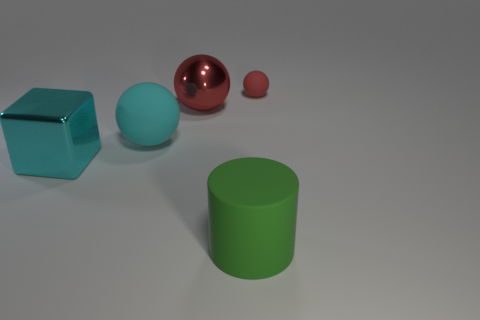Subtract all small rubber spheres. How many spheres are left? 2 Add 5 red rubber spheres. How many objects exist? 10 Subtract all cyan cylinders. How many red balls are left? 2 Subtract 1 cylinders. How many cylinders are left? 0 Subtract all blocks. How many objects are left? 4 Add 2 balls. How many balls are left? 5 Add 4 blocks. How many blocks exist? 5 Subtract all red spheres. How many spheres are left? 1 Subtract 0 blue balls. How many objects are left? 5 Subtract all green blocks. Subtract all cyan balls. How many blocks are left? 1 